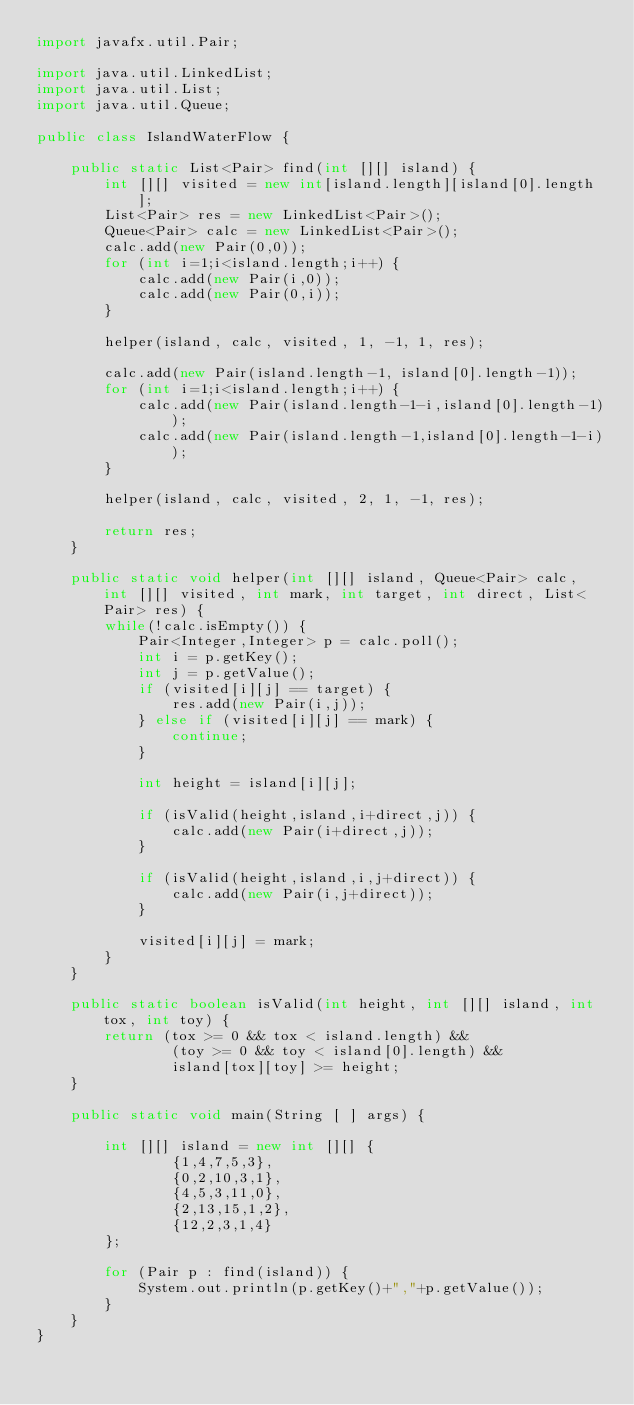<code> <loc_0><loc_0><loc_500><loc_500><_Java_>import javafx.util.Pair;

import java.util.LinkedList;
import java.util.List;
import java.util.Queue;

public class IslandWaterFlow {

    public static List<Pair> find(int [][] island) {
        int [][] visited = new int[island.length][island[0].length];
        List<Pair> res = new LinkedList<Pair>();
        Queue<Pair> calc = new LinkedList<Pair>();
        calc.add(new Pair(0,0));
        for (int i=1;i<island.length;i++) {
            calc.add(new Pair(i,0));
            calc.add(new Pair(0,i));
        }

        helper(island, calc, visited, 1, -1, 1, res);

        calc.add(new Pair(island.length-1, island[0].length-1));
        for (int i=1;i<island.length;i++) {
            calc.add(new Pair(island.length-1-i,island[0].length-1));
            calc.add(new Pair(island.length-1,island[0].length-1-i));
        }

        helper(island, calc, visited, 2, 1, -1, res);

        return res;
    }

    public static void helper(int [][] island, Queue<Pair> calc, int [][] visited, int mark, int target, int direct, List<Pair> res) {
        while(!calc.isEmpty()) {
            Pair<Integer,Integer> p = calc.poll();
            int i = p.getKey();
            int j = p.getValue();
            if (visited[i][j] == target) {
                res.add(new Pair(i,j));
            } else if (visited[i][j] == mark) {
                continue;
            }

            int height = island[i][j];

            if (isValid(height,island,i+direct,j)) {
                calc.add(new Pair(i+direct,j));
            }

            if (isValid(height,island,i,j+direct)) {
                calc.add(new Pair(i,j+direct));
            }

            visited[i][j] = mark;
        }
    }

    public static boolean isValid(int height, int [][] island, int tox, int toy) {
        return (tox >= 0 && tox < island.length) &&
                (toy >= 0 && toy < island[0].length) &&
                island[tox][toy] >= height;
    }

    public static void main(String [ ] args) {

        int [][] island = new int [][] {
                {1,4,7,5,3},
                {0,2,10,3,1},
                {4,5,3,11,0},
                {2,13,15,1,2},
                {12,2,3,1,4}
        };

        for (Pair p : find(island)) {
            System.out.println(p.getKey()+","+p.getValue());
        }
    }
}
</code> 